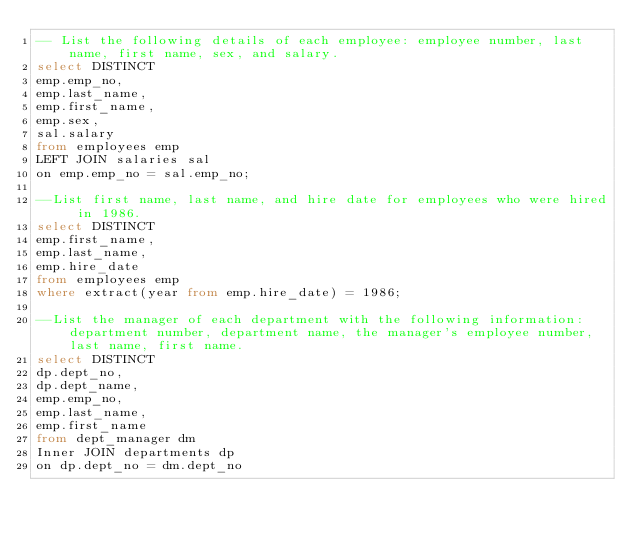<code> <loc_0><loc_0><loc_500><loc_500><_SQL_>-- List the following details of each employee: employee number, last name, first name, sex, and salary.
select DISTINCT
emp.emp_no,
emp.last_name,
emp.first_name,
emp.sex,
sal.salary
from employees emp
LEFT JOIN salaries sal
on emp.emp_no = sal.emp_no;

--List first name, last name, and hire date for employees who were hired in 1986.
select DISTINCT
emp.first_name,
emp.last_name,
emp.hire_date
from employees emp
where extract(year from emp.hire_date) = 1986;

--List the manager of each department with the following information: department number, department name, the manager's employee number, last name, first name.
select DISTINCT
dp.dept_no,
dp.dept_name,
emp.emp_no,
emp.last_name,
emp.first_name
from dept_manager dm
Inner JOIN departments dp
on dp.dept_no = dm.dept_no</code> 